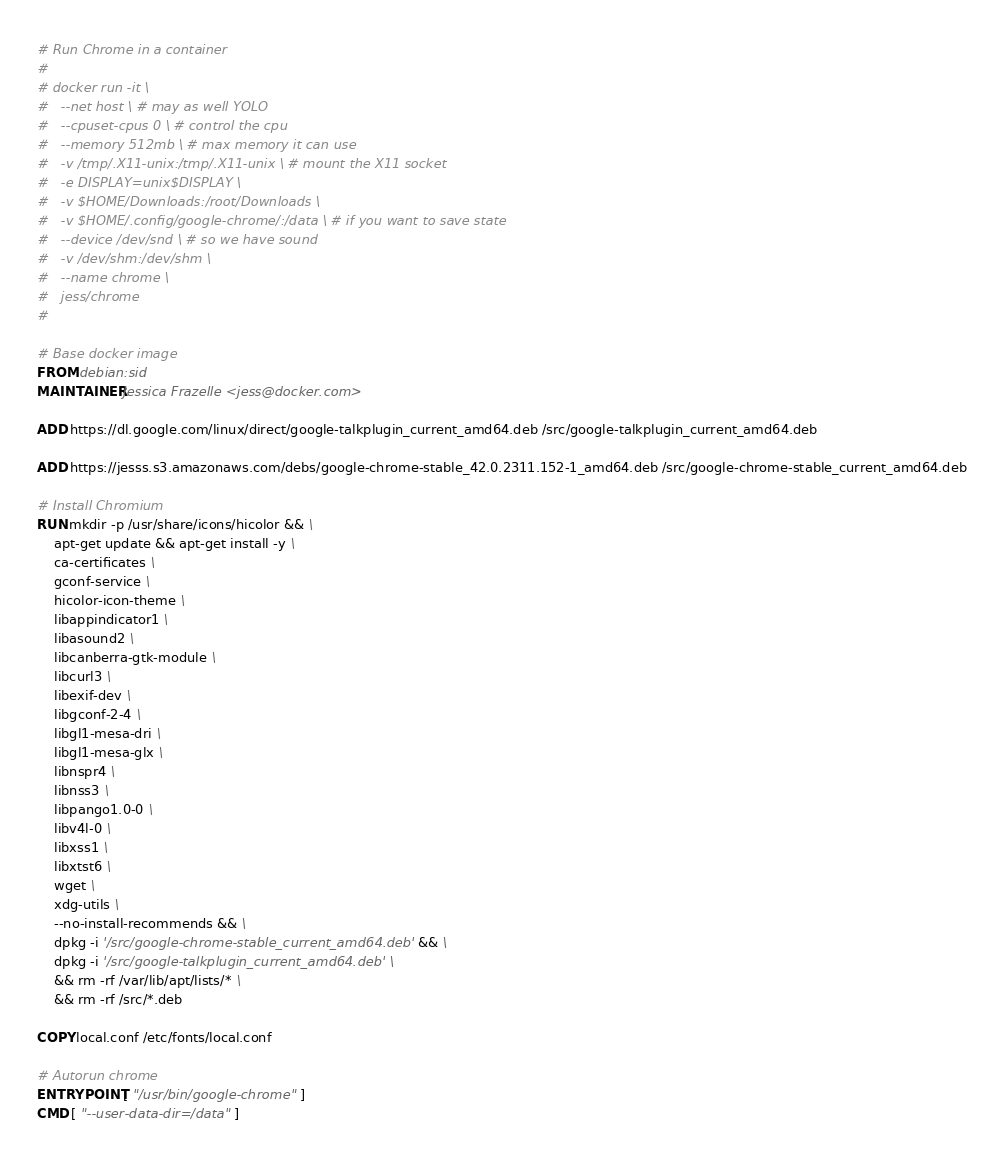Convert code to text. <code><loc_0><loc_0><loc_500><loc_500><_Dockerfile_># Run Chrome in a container
#
# docker run -it \
#	--net host \ # may as well YOLO
#	--cpuset-cpus 0 \ # control the cpu
#	--memory 512mb \ # max memory it can use
#	-v /tmp/.X11-unix:/tmp/.X11-unix \ # mount the X11 socket
#	-e DISPLAY=unix$DISPLAY \
#	-v $HOME/Downloads:/root/Downloads \
#	-v $HOME/.config/google-chrome/:/data \ # if you want to save state
#	--device /dev/snd \ # so we have sound
#	-v /dev/shm:/dev/shm \
#	--name chrome \
#	jess/chrome
#

# Base docker image
FROM debian:sid
MAINTAINER Jessica Frazelle <jess@docker.com>

ADD https://dl.google.com/linux/direct/google-talkplugin_current_amd64.deb /src/google-talkplugin_current_amd64.deb

ADD https://jesss.s3.amazonaws.com/debs/google-chrome-stable_42.0.2311.152-1_amd64.deb /src/google-chrome-stable_current_amd64.deb

# Install Chromium
RUN mkdir -p /usr/share/icons/hicolor && \
	apt-get update && apt-get install -y \
	ca-certificates \
	gconf-service \
	hicolor-icon-theme \
	libappindicator1 \
	libasound2 \
	libcanberra-gtk-module \
	libcurl3 \
	libexif-dev \
	libgconf-2-4 \
	libgl1-mesa-dri \
	libgl1-mesa-glx \
	libnspr4 \
	libnss3 \
	libpango1.0-0 \
	libv4l-0 \
	libxss1 \
	libxtst6 \
	wget \
	xdg-utils \
	--no-install-recommends && \
	dpkg -i '/src/google-chrome-stable_current_amd64.deb' && \
	dpkg -i '/src/google-talkplugin_current_amd64.deb' \
	&& rm -rf /var/lib/apt/lists/* \
	&& rm -rf /src/*.deb

COPY local.conf /etc/fonts/local.conf

# Autorun chrome
ENTRYPOINT [ "/usr/bin/google-chrome" ]
CMD [ "--user-data-dir=/data" ]
</code> 